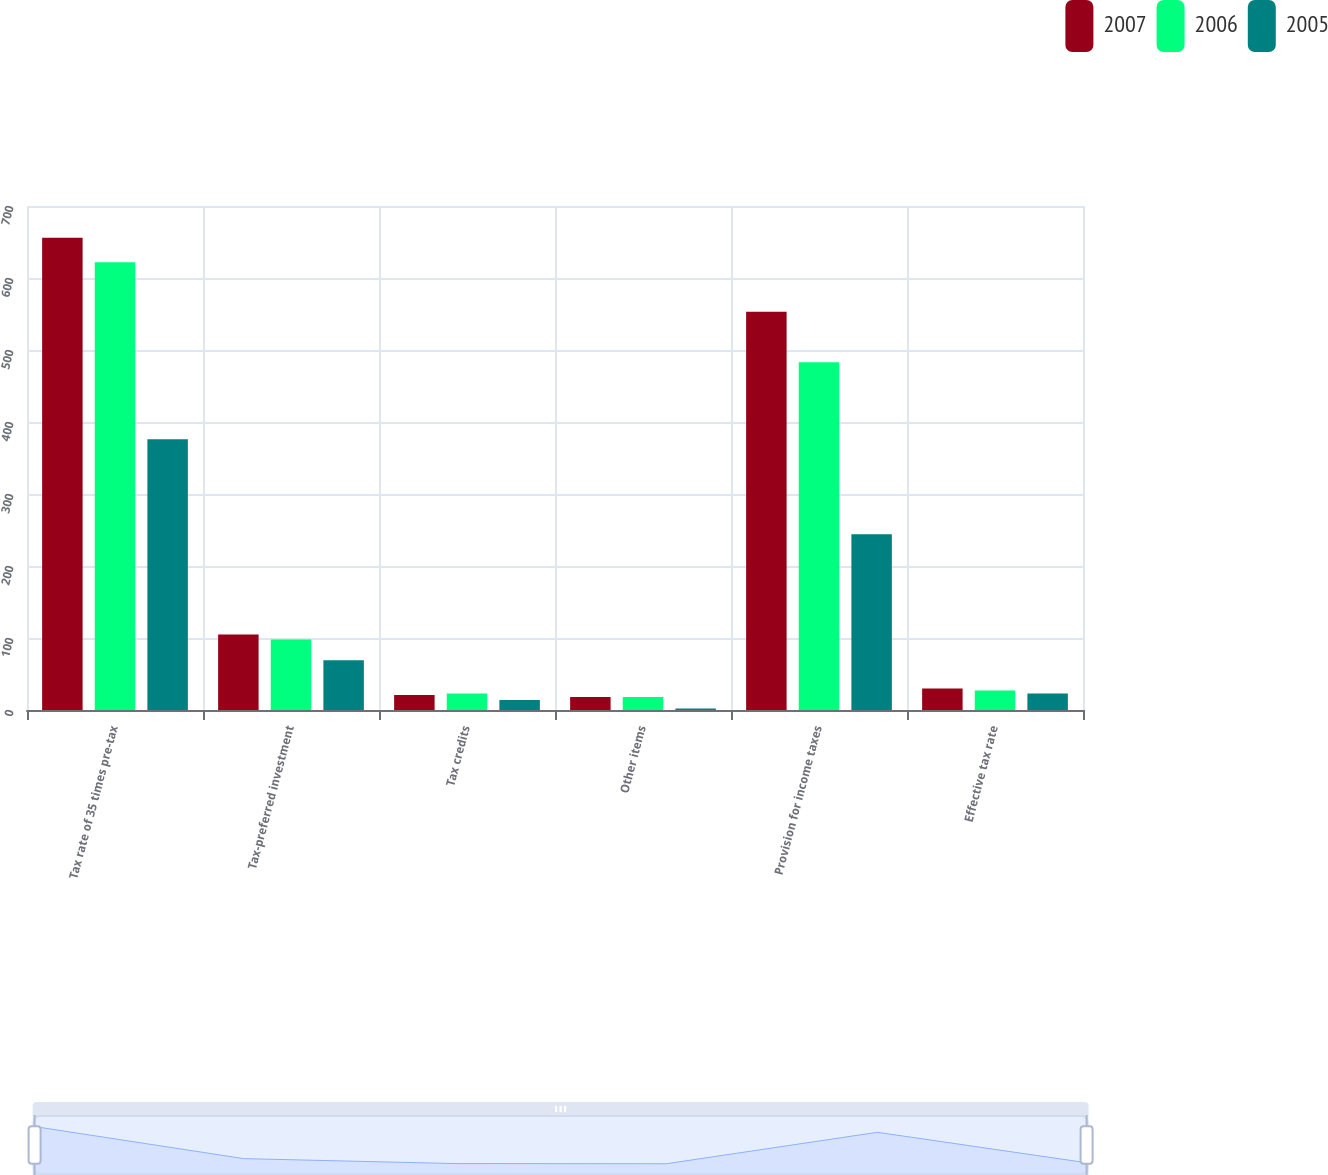Convert chart. <chart><loc_0><loc_0><loc_500><loc_500><stacked_bar_chart><ecel><fcel>Tax rate of 35 times pre-tax<fcel>Tax-preferred investment<fcel>Tax credits<fcel>Other items<fcel>Provision for income taxes<fcel>Effective tax rate<nl><fcel>2007<fcel>656<fcel>105<fcel>21<fcel>18<fcel>553<fcel>30<nl><fcel>2006<fcel>622<fcel>98<fcel>23<fcel>18<fcel>483<fcel>27<nl><fcel>2005<fcel>376<fcel>69<fcel>14<fcel>2<fcel>244<fcel>23<nl></chart> 